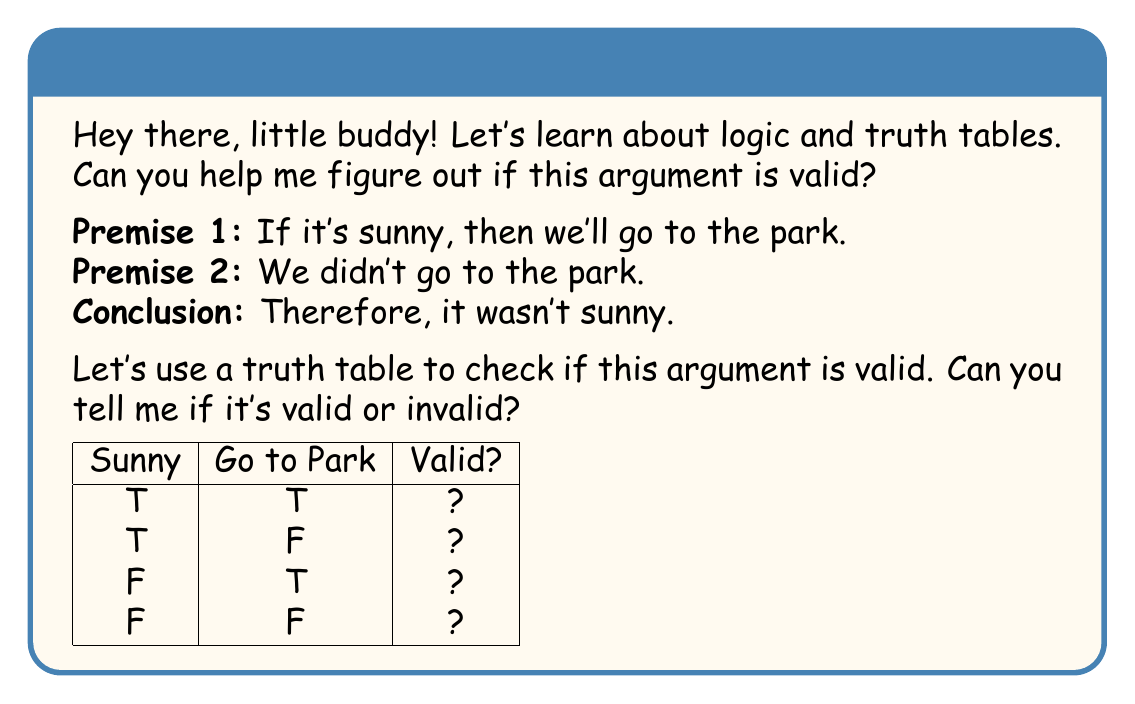Help me with this question. Great question! Let's break this down step-by-step:

1. First, let's define our variables:
   $p$: It's sunny
   $q$: We'll go to the park

2. Now, let's write out the logical form of the argument:
   Premise 1: $p \rightarrow q$
   Premise 2: $\neg q$
   Conclusion: $\therefore \neg p$

3. We'll create a truth table with columns for $p$, $q$, $p \rightarrow q$, $\neg q$, and $\neg p$:

   $$\begin{array}{|c|c|c|c|c|}
   \hline
   p & q & p \rightarrow q & \neg q & \neg p \\
   \hline
   T & T & T & F & F \\
   T & F & F & T & F \\
   F & T & T & F & T \\
   F & F & T & T & T \\
   \hline
   \end{array}$$

4. We're looking for rows where both premises are true ($(p \rightarrow q)$ and $\neg q$) and checking if the conclusion ($\neg p$) is also true in those cases.

5. We can see that in the second row:
   - $p \rightarrow q$ is false
   - $\neg q$ is true
   - $\neg p$ is false

6. This means there's a case where both premises are true, but the conclusion is false.

7. For an argument to be valid, the conclusion must be true in all cases where the premises are true. Since we found a case where this doesn't hold, the argument is invalid.

This type of argument is called "denying the consequent" and is a common logical fallacy.
Answer: Invalid 